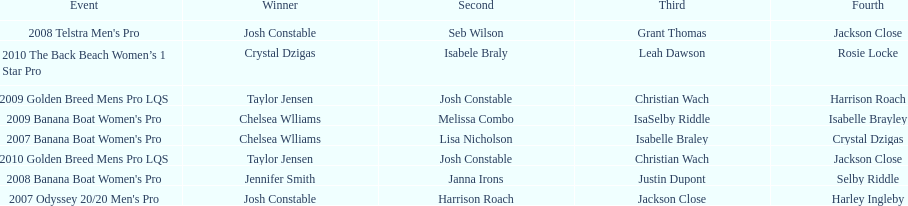In what event did chelsea williams win her first title? 2007 Banana Boat Women's Pro. 